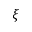<formula> <loc_0><loc_0><loc_500><loc_500>\xi</formula> 